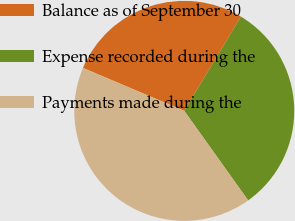Convert chart. <chart><loc_0><loc_0><loc_500><loc_500><pie_chart><fcel>Balance as of September 30<fcel>Expense recorded during the<fcel>Payments made during the<nl><fcel>27.23%<fcel>31.52%<fcel>41.24%<nl></chart> 